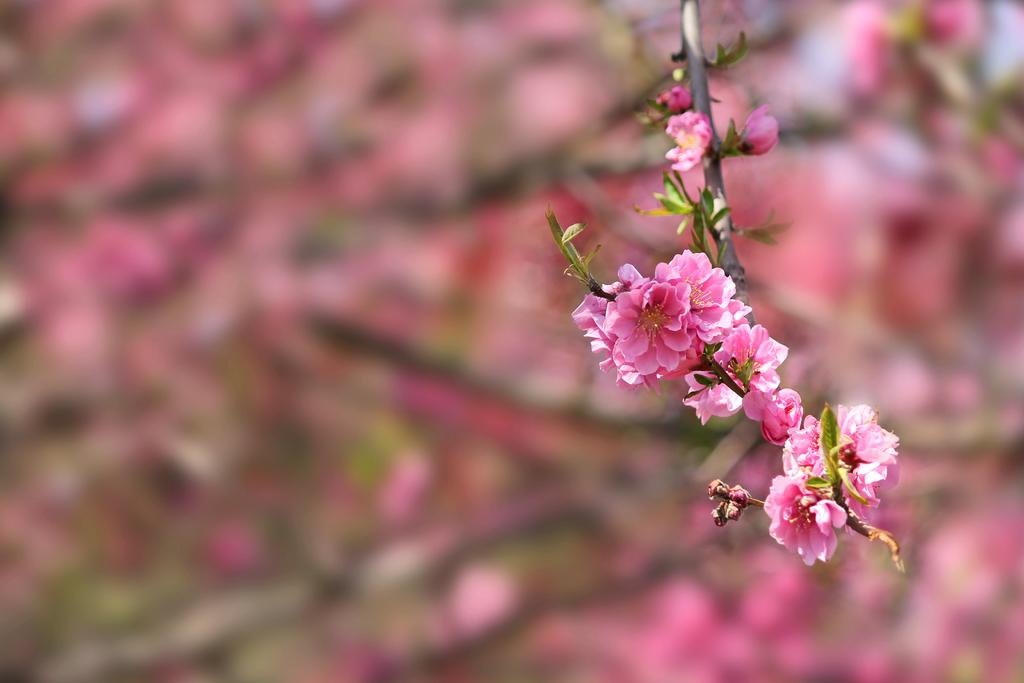What type of plant can be seen in the image? There is a plant with flowers in the image. Can you describe the background of the image? The background of the image is blurry. What type of books does the government use to make decisions in the image? There are no books or references to a government in the image; it features a plant with flowers and a blurry background. 